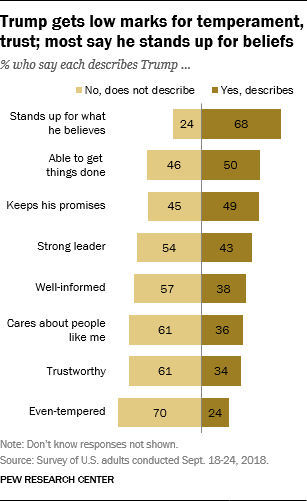Point out several critical features in this image. The average value of the smallest three No bars is approximately 38.33. The value of the 1st Yes bar is 68. 